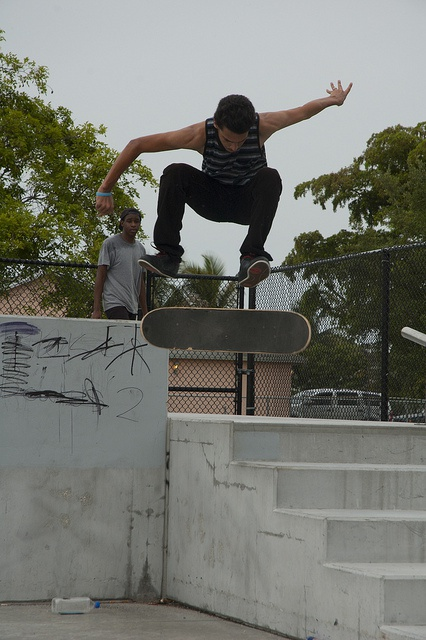Describe the objects in this image and their specific colors. I can see people in darkgray, black, maroon, and gray tones, skateboard in darkgray, black, and gray tones, people in darkgray, gray, black, and darkgreen tones, truck in darkgray, black, and gray tones, and car in darkgray, black, and gray tones in this image. 